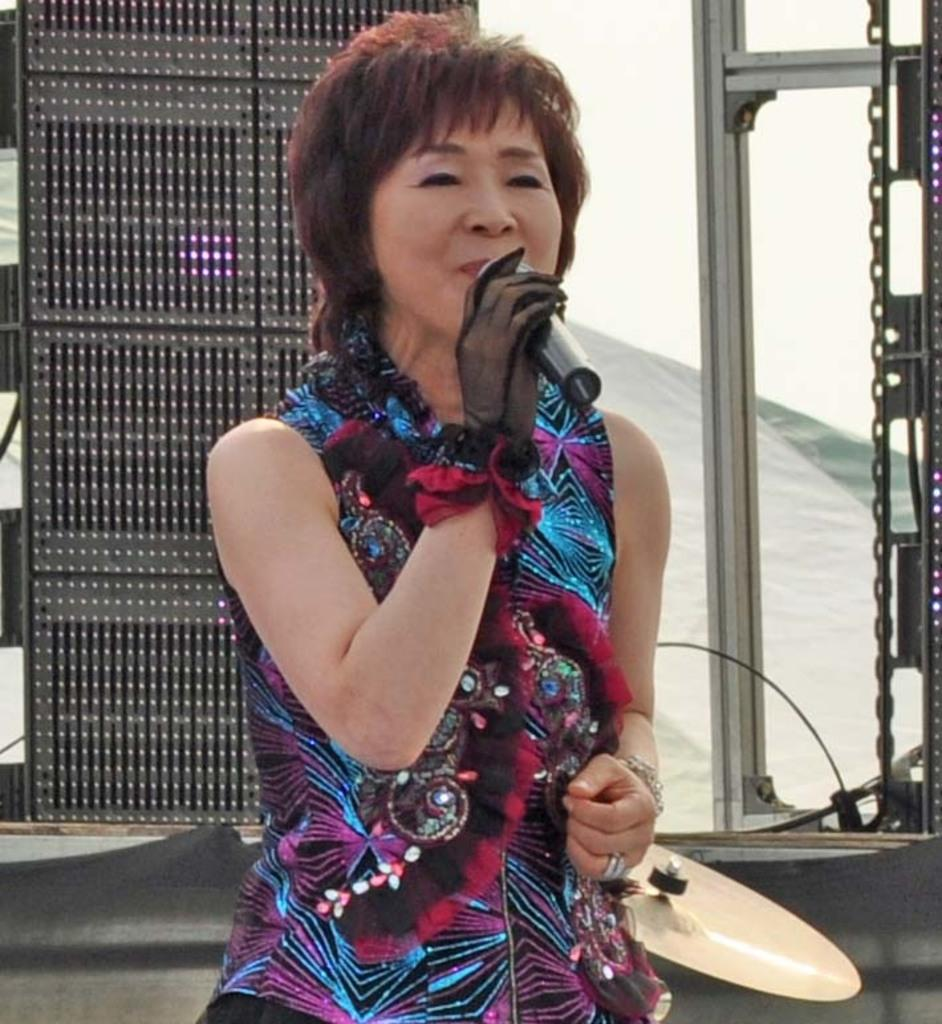Who is the main subject in the image? There is a woman in the image. How is the woman being emphasized in the image? The woman is highlighted. What is the woman holding in the image? The woman is holding a microphone. What other object related to music can be seen in the image? There is a musical instrument in the image. What type of skirt is the woman wearing in the image? There is no skirt visible in the image; the woman is holding a microphone and standing near a musical instrument. 